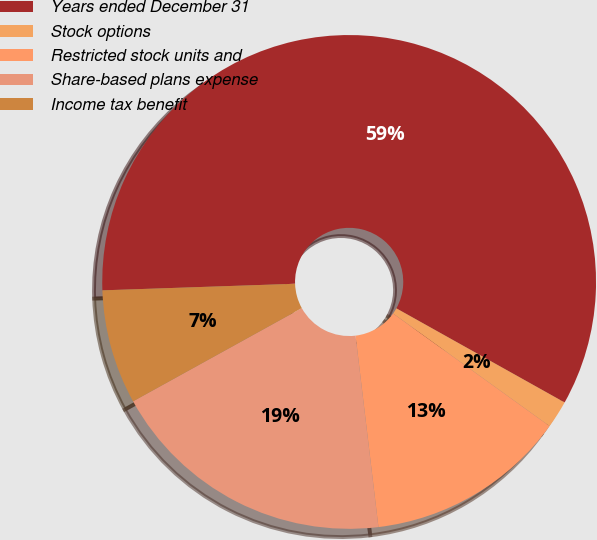Convert chart. <chart><loc_0><loc_0><loc_500><loc_500><pie_chart><fcel>Years ended December 31<fcel>Stock options<fcel>Restricted stock units and<fcel>Share-based plans expense<fcel>Income tax benefit<nl><fcel>58.66%<fcel>1.81%<fcel>13.18%<fcel>18.86%<fcel>7.49%<nl></chart> 